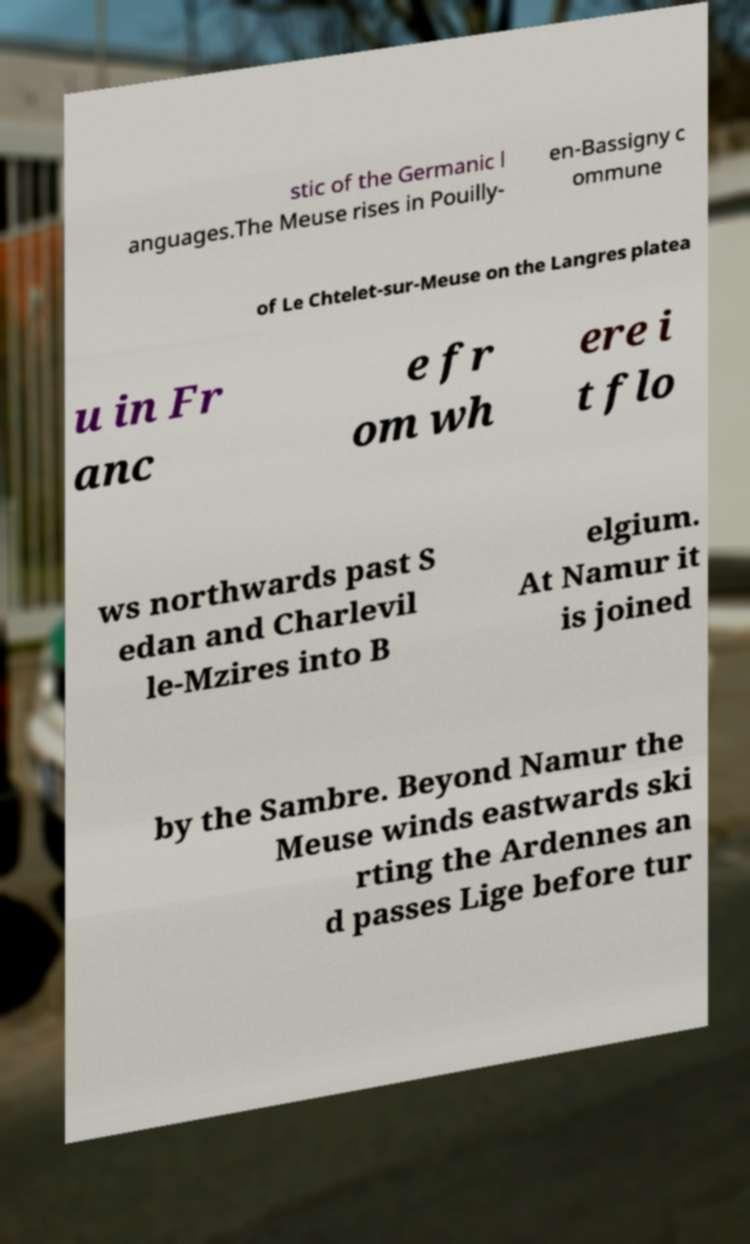Please read and relay the text visible in this image. What does it say? stic of the Germanic l anguages.The Meuse rises in Pouilly- en-Bassigny c ommune of Le Chtelet-sur-Meuse on the Langres platea u in Fr anc e fr om wh ere i t flo ws northwards past S edan and Charlevil le-Mzires into B elgium. At Namur it is joined by the Sambre. Beyond Namur the Meuse winds eastwards ski rting the Ardennes an d passes Lige before tur 